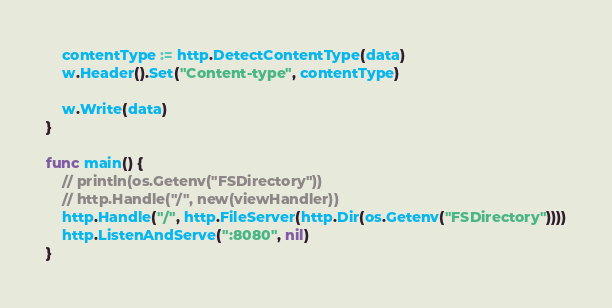Convert code to text. <code><loc_0><loc_0><loc_500><loc_500><_Go_>	contentType := http.DetectContentType(data)
	w.Header().Set("Content-type", contentType)

	w.Write(data)
}

func main() {
	// println(os.Getenv("FSDirectory"))
	// http.Handle("/", new(viewHandler))
	http.Handle("/", http.FileServer(http.Dir(os.Getenv("FSDirectory"))))
	http.ListenAndServe(":8080", nil)
}
</code> 